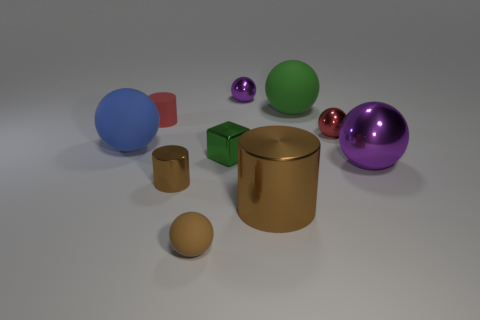How many brown cylinders must be subtracted to get 1 brown cylinders? 1 Subtract 2 spheres. How many spheres are left? 4 Subtract all red balls. How many balls are left? 5 Subtract all large purple balls. How many balls are left? 5 Subtract all cyan balls. Subtract all brown cylinders. How many balls are left? 6 Subtract all spheres. How many objects are left? 4 Add 2 green rubber objects. How many green rubber objects exist? 3 Subtract 0 cyan cylinders. How many objects are left? 10 Subtract all large rubber objects. Subtract all big green rubber spheres. How many objects are left? 7 Add 8 red matte things. How many red matte things are left? 9 